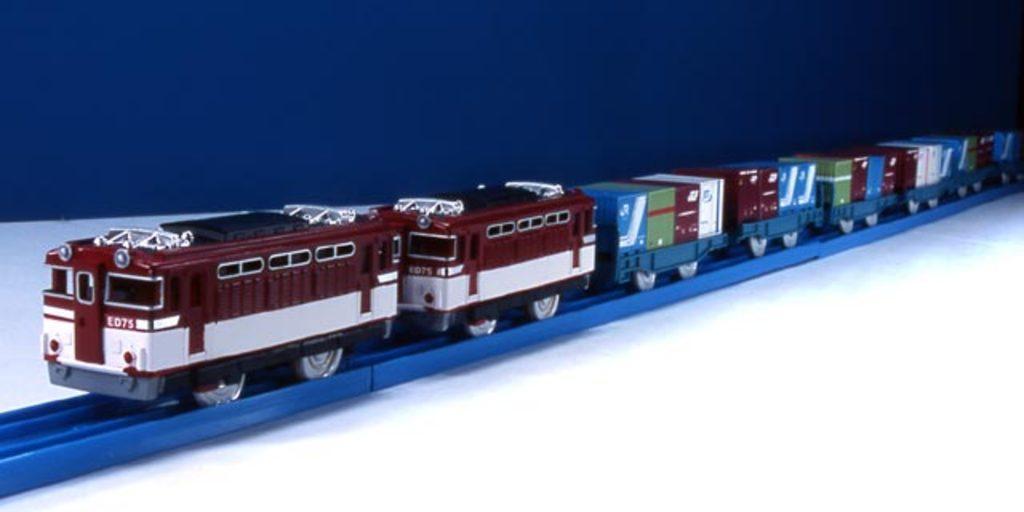Describe this image in one or two sentences. In this image we can see a train on the blue color track which is placed on the white color surface. The background of the image is in blue color. 